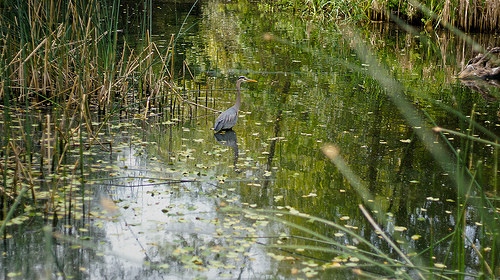<image>
Is the bird above the water? Yes. The bird is positioned above the water in the vertical space, higher up in the scene. 